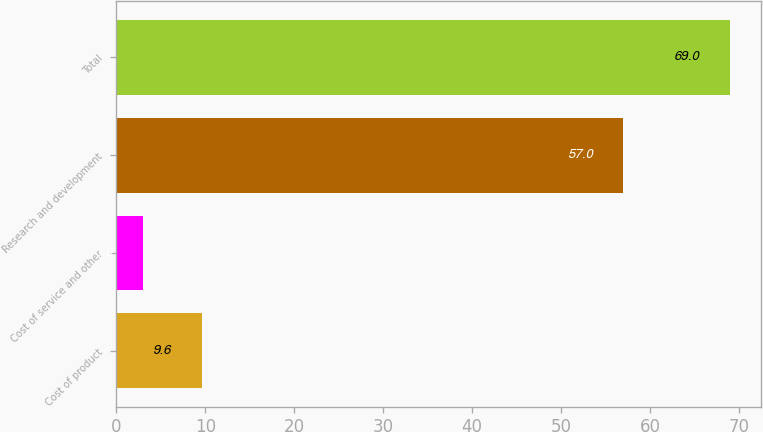Convert chart. <chart><loc_0><loc_0><loc_500><loc_500><bar_chart><fcel>Cost of product<fcel>Cost of service and other<fcel>Research and development<fcel>Total<nl><fcel>9.6<fcel>3<fcel>57<fcel>69<nl></chart> 